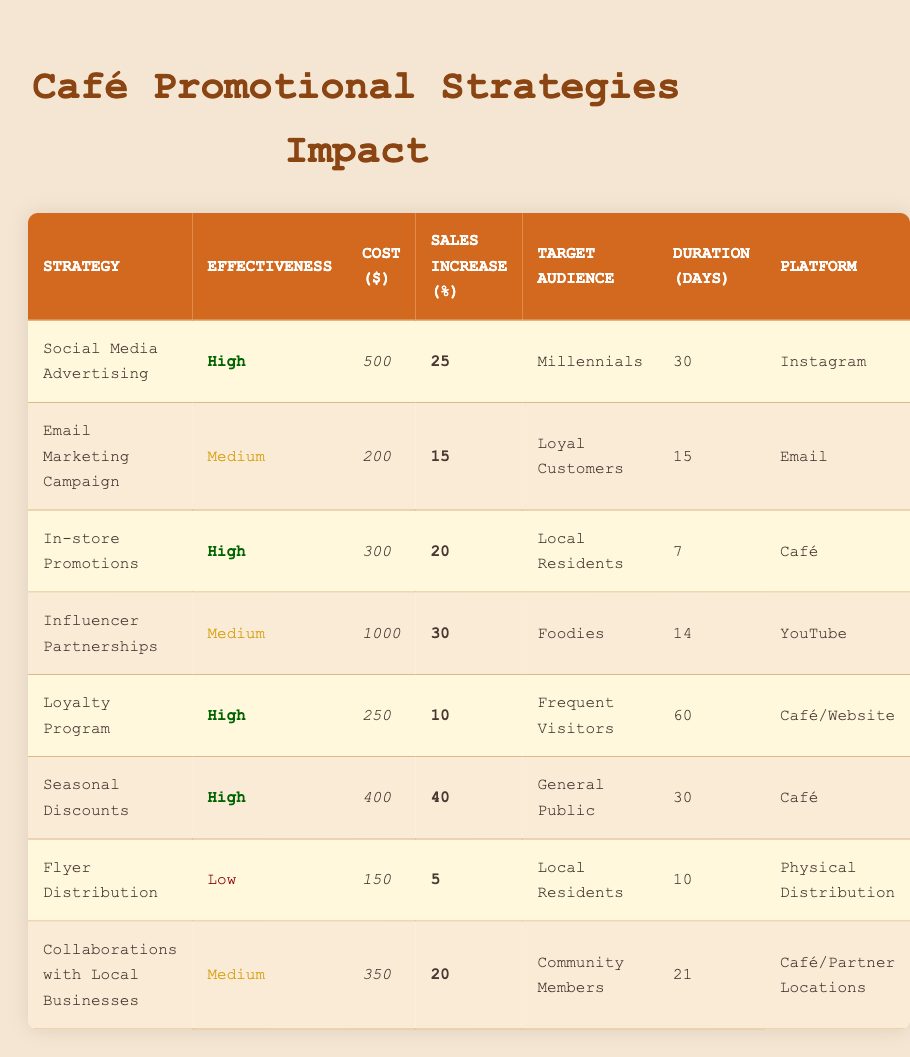What is the effectiveness of the "In-store Promotions" strategy? The effectiveness of the "In-store Promotions" strategy can be found in the second column of the corresponding row in the table, where it states "High".
Answer: High What is the total cost of all promotional strategies? To find the total cost, we need to sum the costs of each strategy: 500 + 200 + 300 + 1000 + 250 + 400 + 150 + 350 = 2950.
Answer: 2950 Which strategy has the highest sales increase percentage, and what is that percentage? By reviewing the "Sales Increase (%)" column, we find that "Seasonal Discounts" has the highest percentage at 40%.
Answer: Seasonal Discounts, 40 Is the "Email Marketing Campaign" considered effective? The effectiveness of the "Email Marketing Campaign" is listed as "Medium", which indicates it is considered effective but not as strongly as strategies rated "High".
Answer: Yes What is the average sales increase percentage among all strategies? To calculate the average, we sum all the sales increase percentages: (25 + 15 + 20 + 30 + 10 + 40 + 5 + 20) = 175. Then divide by the number of strategies, which is 8, resulting in an average of 175 / 8 = 21.875.
Answer: 21.875 Which promotional strategy targets "Foodies" and what is its cost? In the table, the strategy that targets "Foodies" is "Influencer Partnerships" and its cost is $1000.
Answer: Influencer Partnerships, 1000 Are "Seasonal Discounts" and "Flyer Distribution" both effective strategies? "Seasonal Discounts" is listed with "High" effectiveness, while "Flyer Distribution" has "Low" effectiveness, indicating that only one of them is considered effective.
Answer: No How long do "Loyalty Program" promotions typically last? The duration for the "Loyalty Program" is indicated in the table as 60 days.
Answer: 60 days What is the difference in sales increase percentage between "Social Media Advertising" and "Email Marketing Campaign"? The sales increase for "Social Media Advertising" is 25%, and for "Email Marketing Campaign", it is 15%. The difference can be calculated as 25 - 15 = 10%.
Answer: 10% 